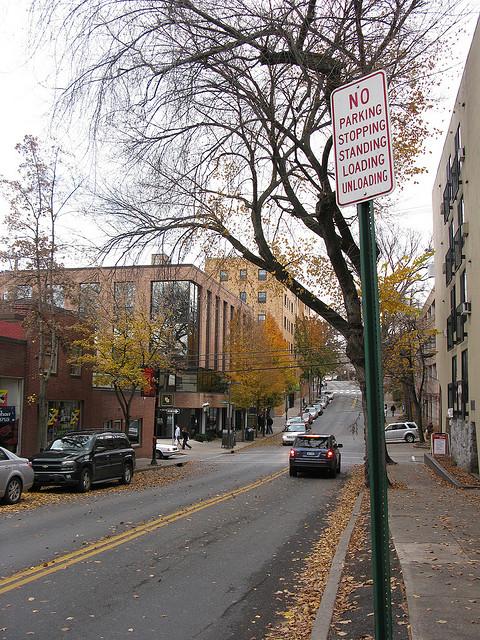What color is the stripe in the road?
Quick response, please. Yellow. Is this a city street?
Give a very brief answer. Yes. Are there leaves on the road?
Quick response, please. Yes. 